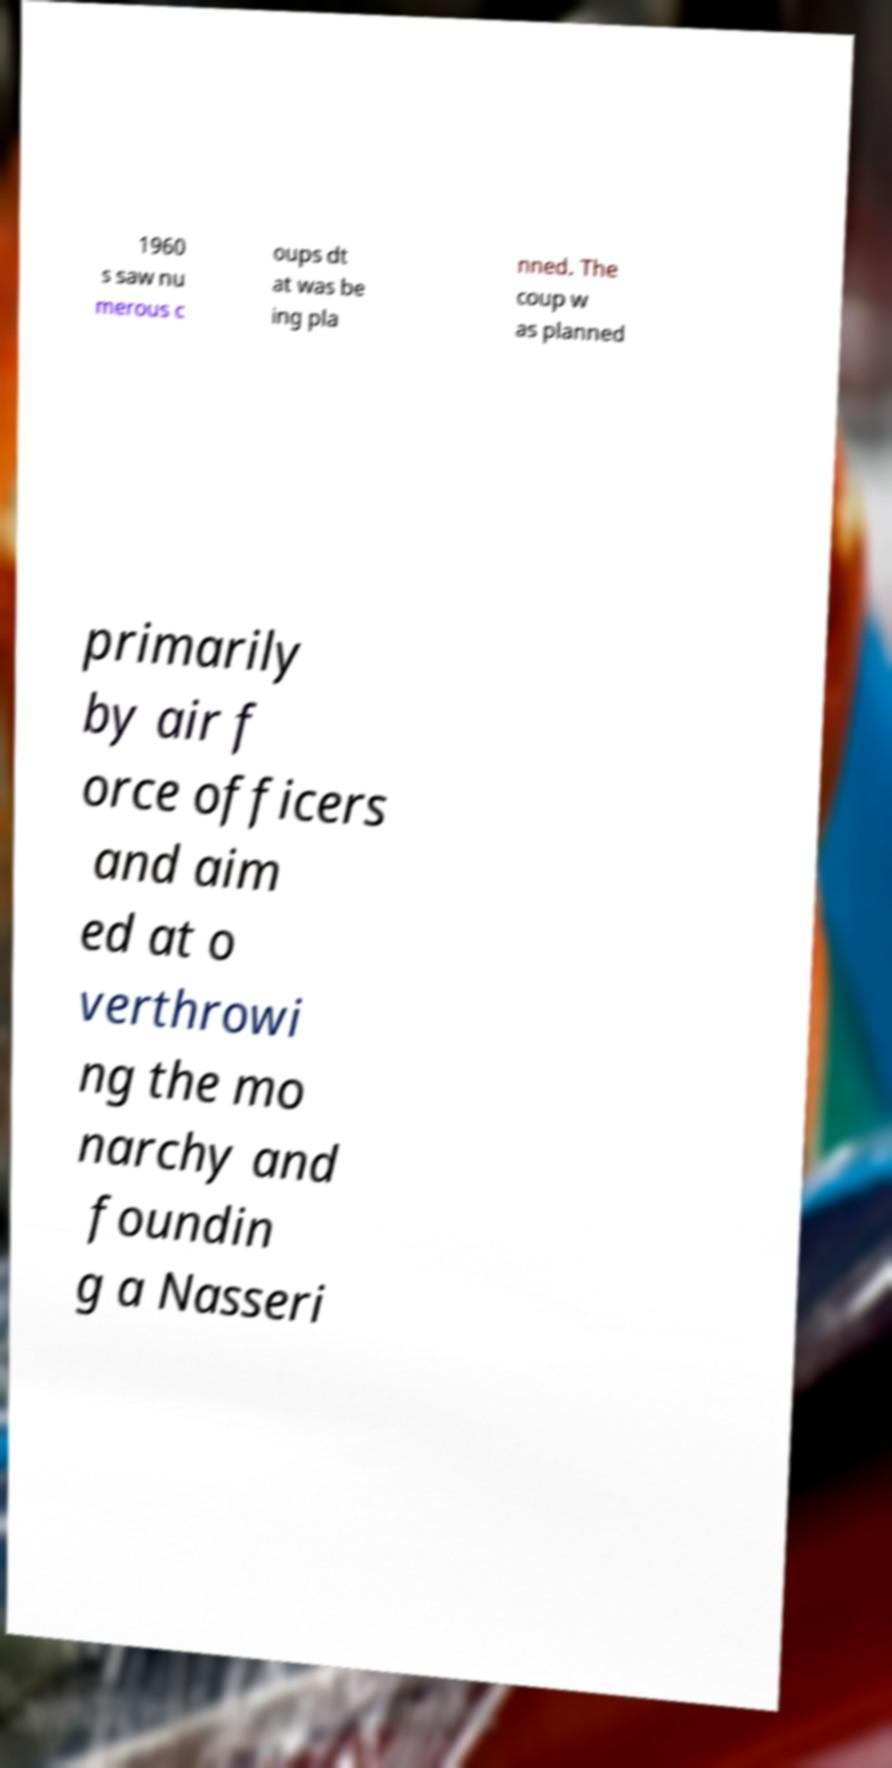Could you assist in decoding the text presented in this image and type it out clearly? 1960 s saw nu merous c oups dt at was be ing pla nned. The coup w as planned primarily by air f orce officers and aim ed at o verthrowi ng the mo narchy and foundin g a Nasseri 